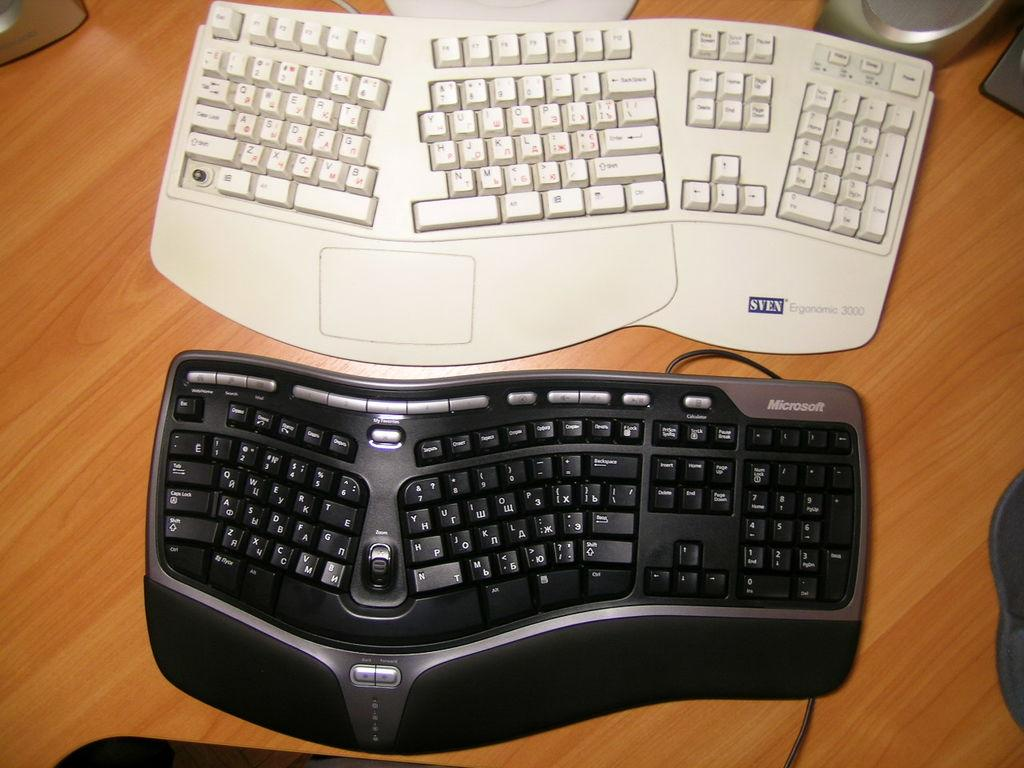Provide a one-sentence caption for the provided image. A black Microsoft keyboard is next to a white keyboard. 